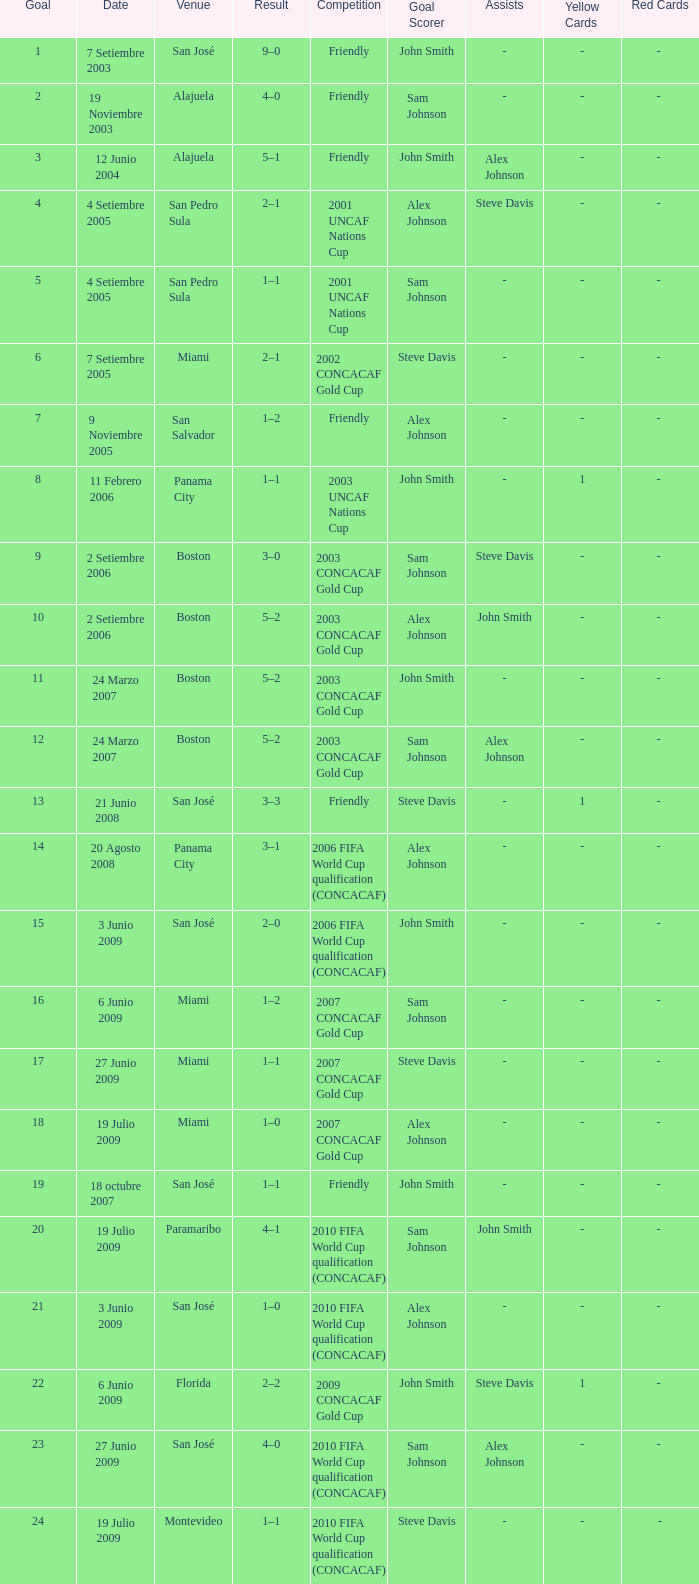How was the competition in which 6 goals were made? 2002 CONCACAF Gold Cup. 